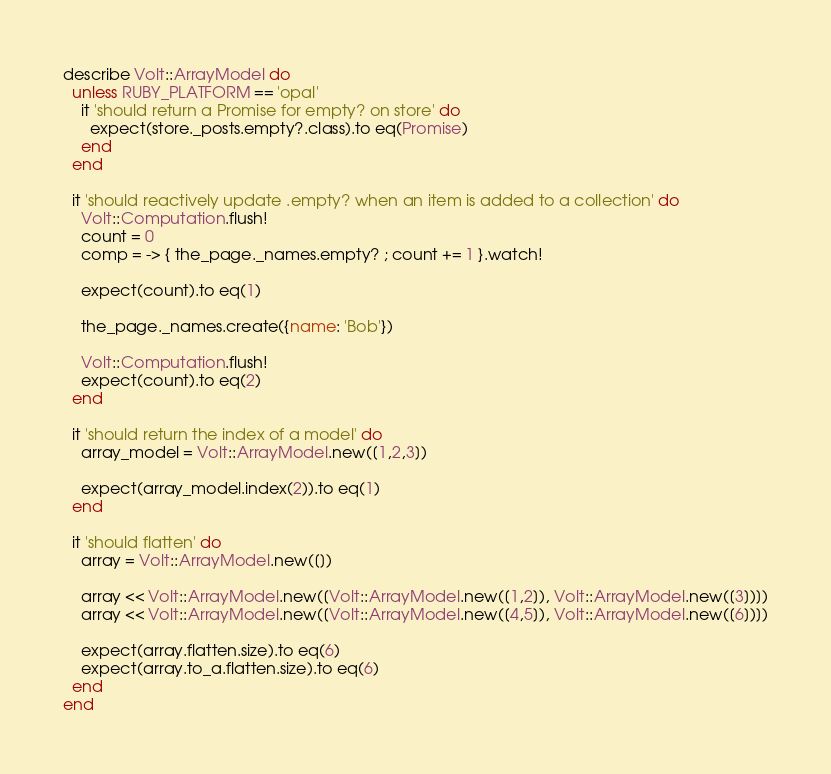<code> <loc_0><loc_0><loc_500><loc_500><_Ruby_>describe Volt::ArrayModel do
  unless RUBY_PLATFORM == 'opal'
    it 'should return a Promise for empty? on store' do
      expect(store._posts.empty?.class).to eq(Promise)
    end
  end

  it 'should reactively update .empty? when an item is added to a collection' do
    Volt::Computation.flush!
    count = 0
    comp = -> { the_page._names.empty? ; count += 1 }.watch!

    expect(count).to eq(1)

    the_page._names.create({name: 'Bob'})

    Volt::Computation.flush!
    expect(count).to eq(2)
  end

  it 'should return the index of a model' do
    array_model = Volt::ArrayModel.new([1,2,3])

    expect(array_model.index(2)).to eq(1)
  end

  it 'should flatten' do
    array = Volt::ArrayModel.new([])

    array << Volt::ArrayModel.new([Volt::ArrayModel.new([1,2]), Volt::ArrayModel.new([3])])
    array << Volt::ArrayModel.new([Volt::ArrayModel.new([4,5]), Volt::ArrayModel.new([6])])

    expect(array.flatten.size).to eq(6)
    expect(array.to_a.flatten.size).to eq(6)
  end
end</code> 